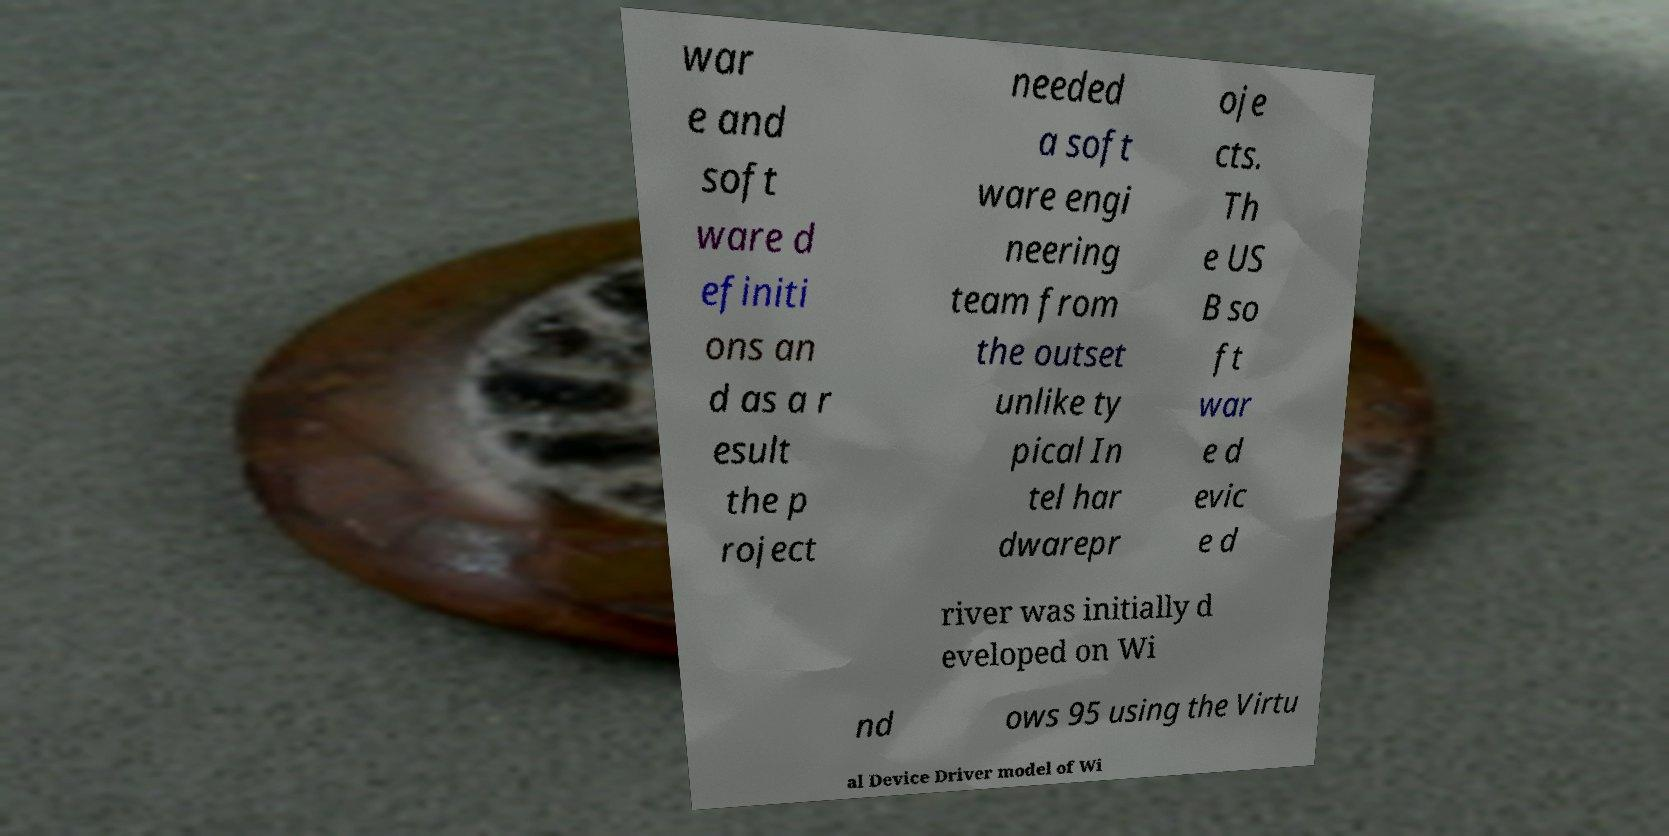For documentation purposes, I need the text within this image transcribed. Could you provide that? war e and soft ware d efiniti ons an d as a r esult the p roject needed a soft ware engi neering team from the outset unlike ty pical In tel har dwarepr oje cts. Th e US B so ft war e d evic e d river was initially d eveloped on Wi nd ows 95 using the Virtu al Device Driver model of Wi 